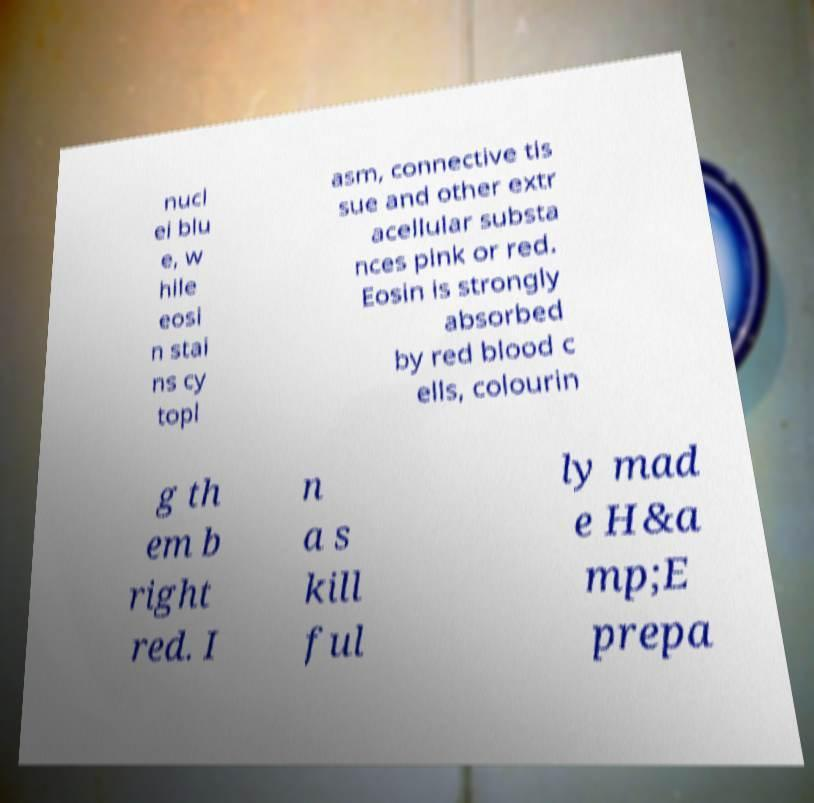Please read and relay the text visible in this image. What does it say? nucl ei blu e, w hile eosi n stai ns cy topl asm, connective tis sue and other extr acellular substa nces pink or red. Eosin is strongly absorbed by red blood c ells, colourin g th em b right red. I n a s kill ful ly mad e H&a mp;E prepa 